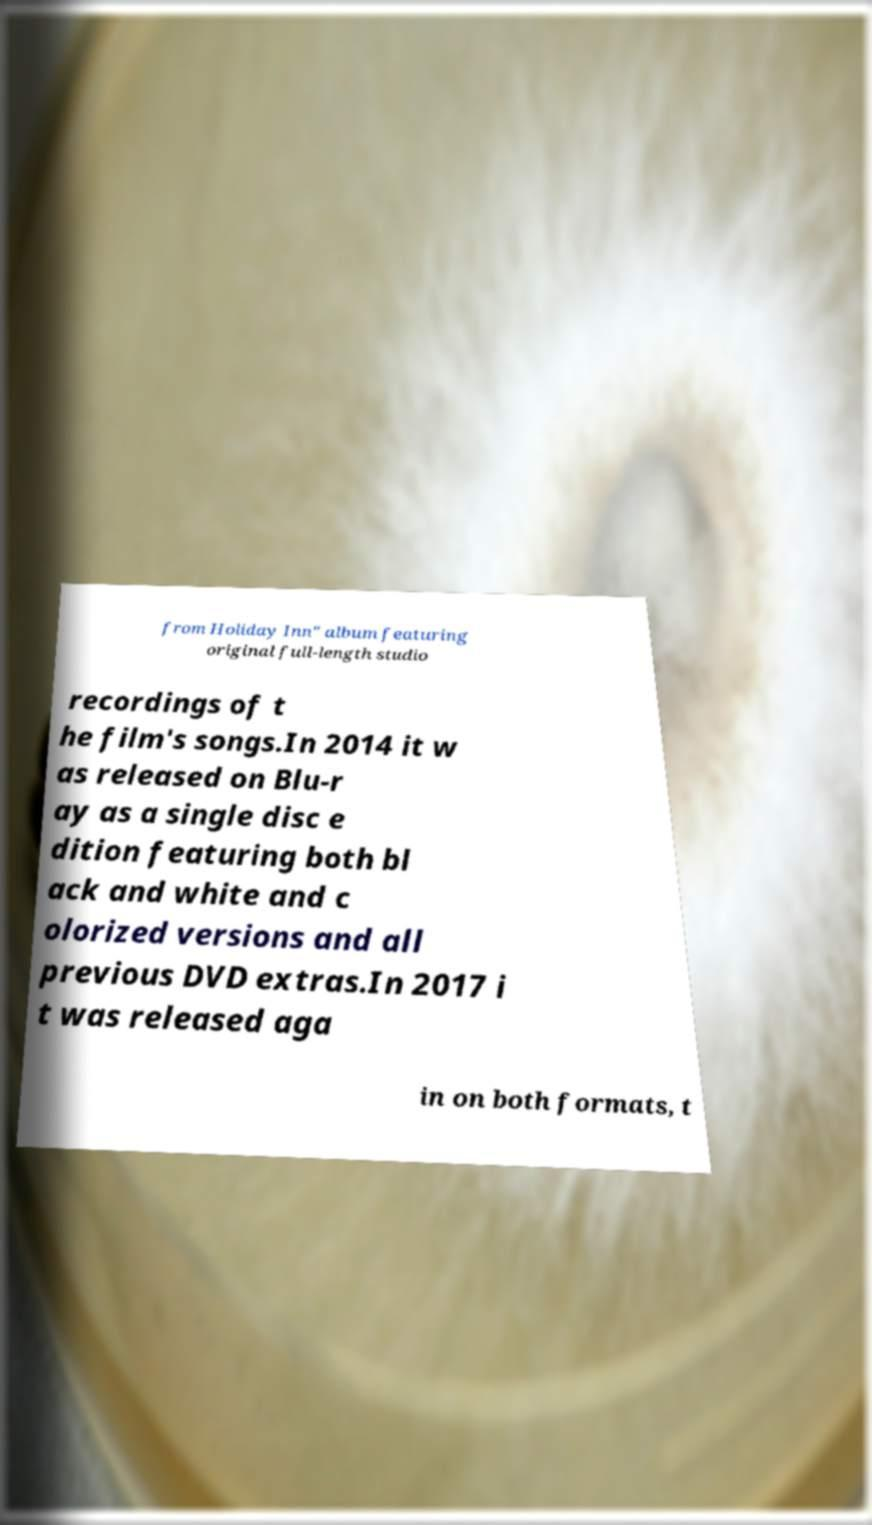There's text embedded in this image that I need extracted. Can you transcribe it verbatim? from Holiday Inn" album featuring original full-length studio recordings of t he film's songs.In 2014 it w as released on Blu-r ay as a single disc e dition featuring both bl ack and white and c olorized versions and all previous DVD extras.In 2017 i t was released aga in on both formats, t 